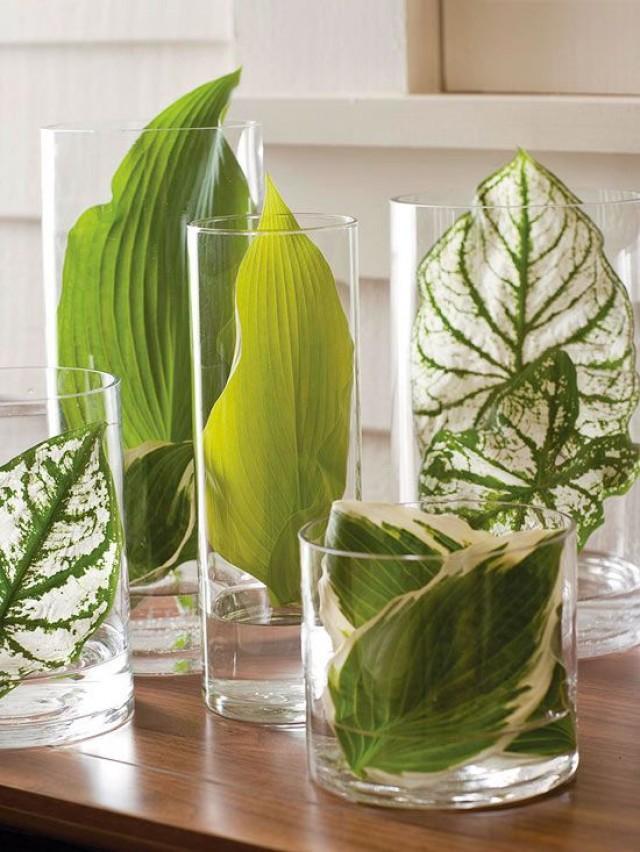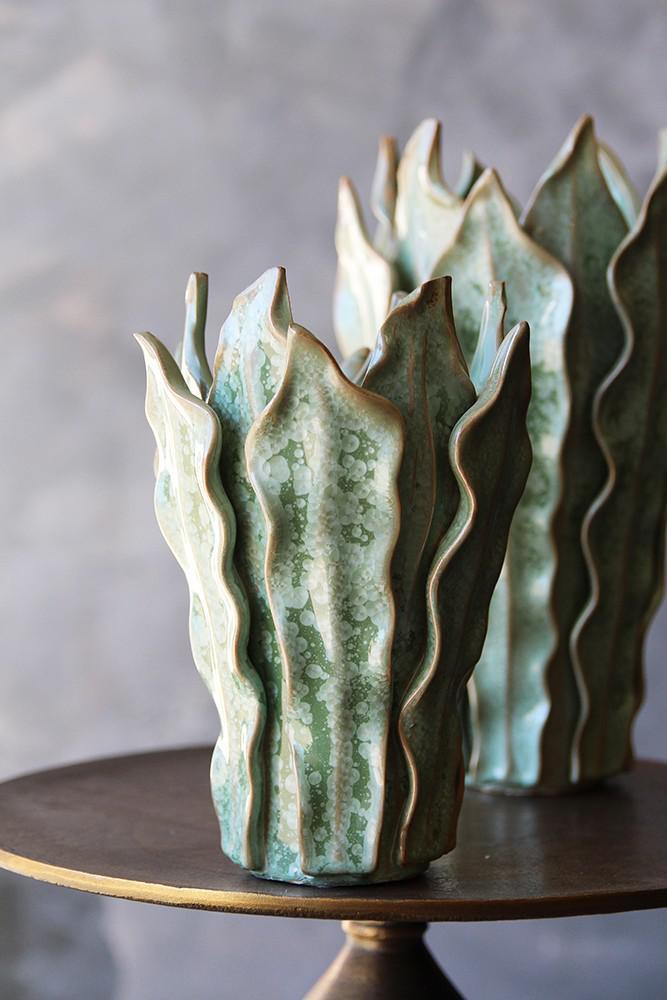The first image is the image on the left, the second image is the image on the right. Considering the images on both sides, is "To the right, it appears as though one branch is held within a vase." valid? Answer yes or no. No. 